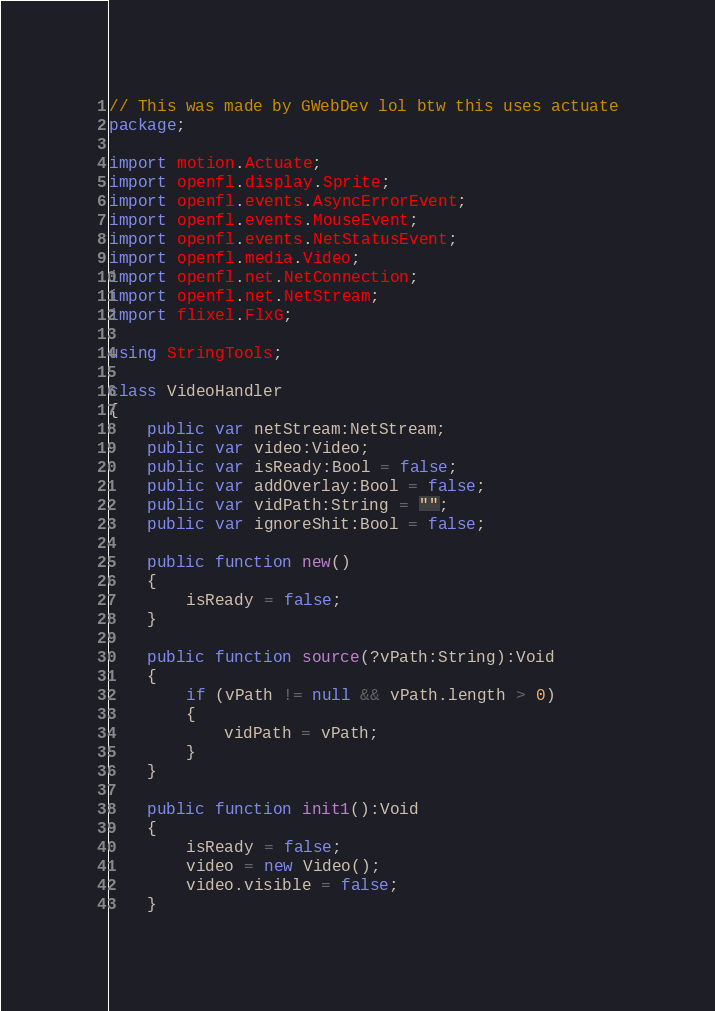Convert code to text. <code><loc_0><loc_0><loc_500><loc_500><_Haxe_>// This was made by GWebDev lol btw this uses actuate
package;

import motion.Actuate;
import openfl.display.Sprite;
import openfl.events.AsyncErrorEvent;
import openfl.events.MouseEvent;
import openfl.events.NetStatusEvent;
import openfl.media.Video;
import openfl.net.NetConnection;
import openfl.net.NetStream;
import flixel.FlxG;

using StringTools;

class VideoHandler
{
	public var netStream:NetStream;
	public var video:Video;
	public var isReady:Bool = false;
	public var addOverlay:Bool = false;
	public var vidPath:String = "";
	public var ignoreShit:Bool = false;

	public function new()
	{
		isReady = false;
	}

	public function source(?vPath:String):Void
	{
		if (vPath != null && vPath.length > 0)
		{
			vidPath = vPath;
		}
	}

	public function init1():Void
	{
		isReady = false;
		video = new Video();
		video.visible = false;
	}
</code> 